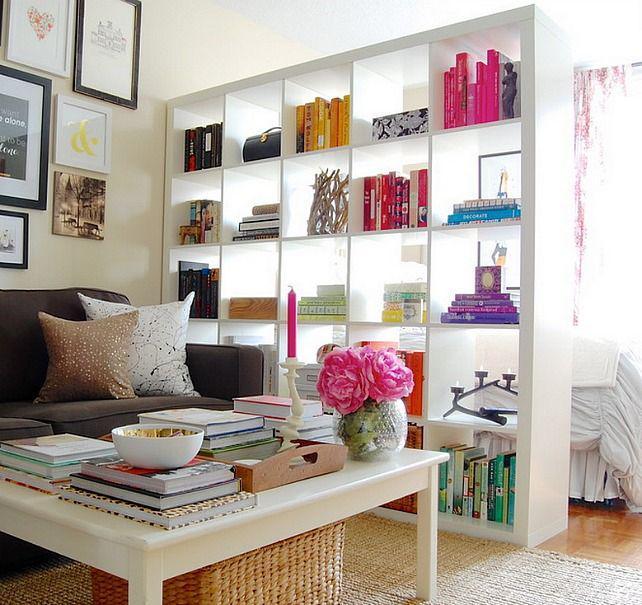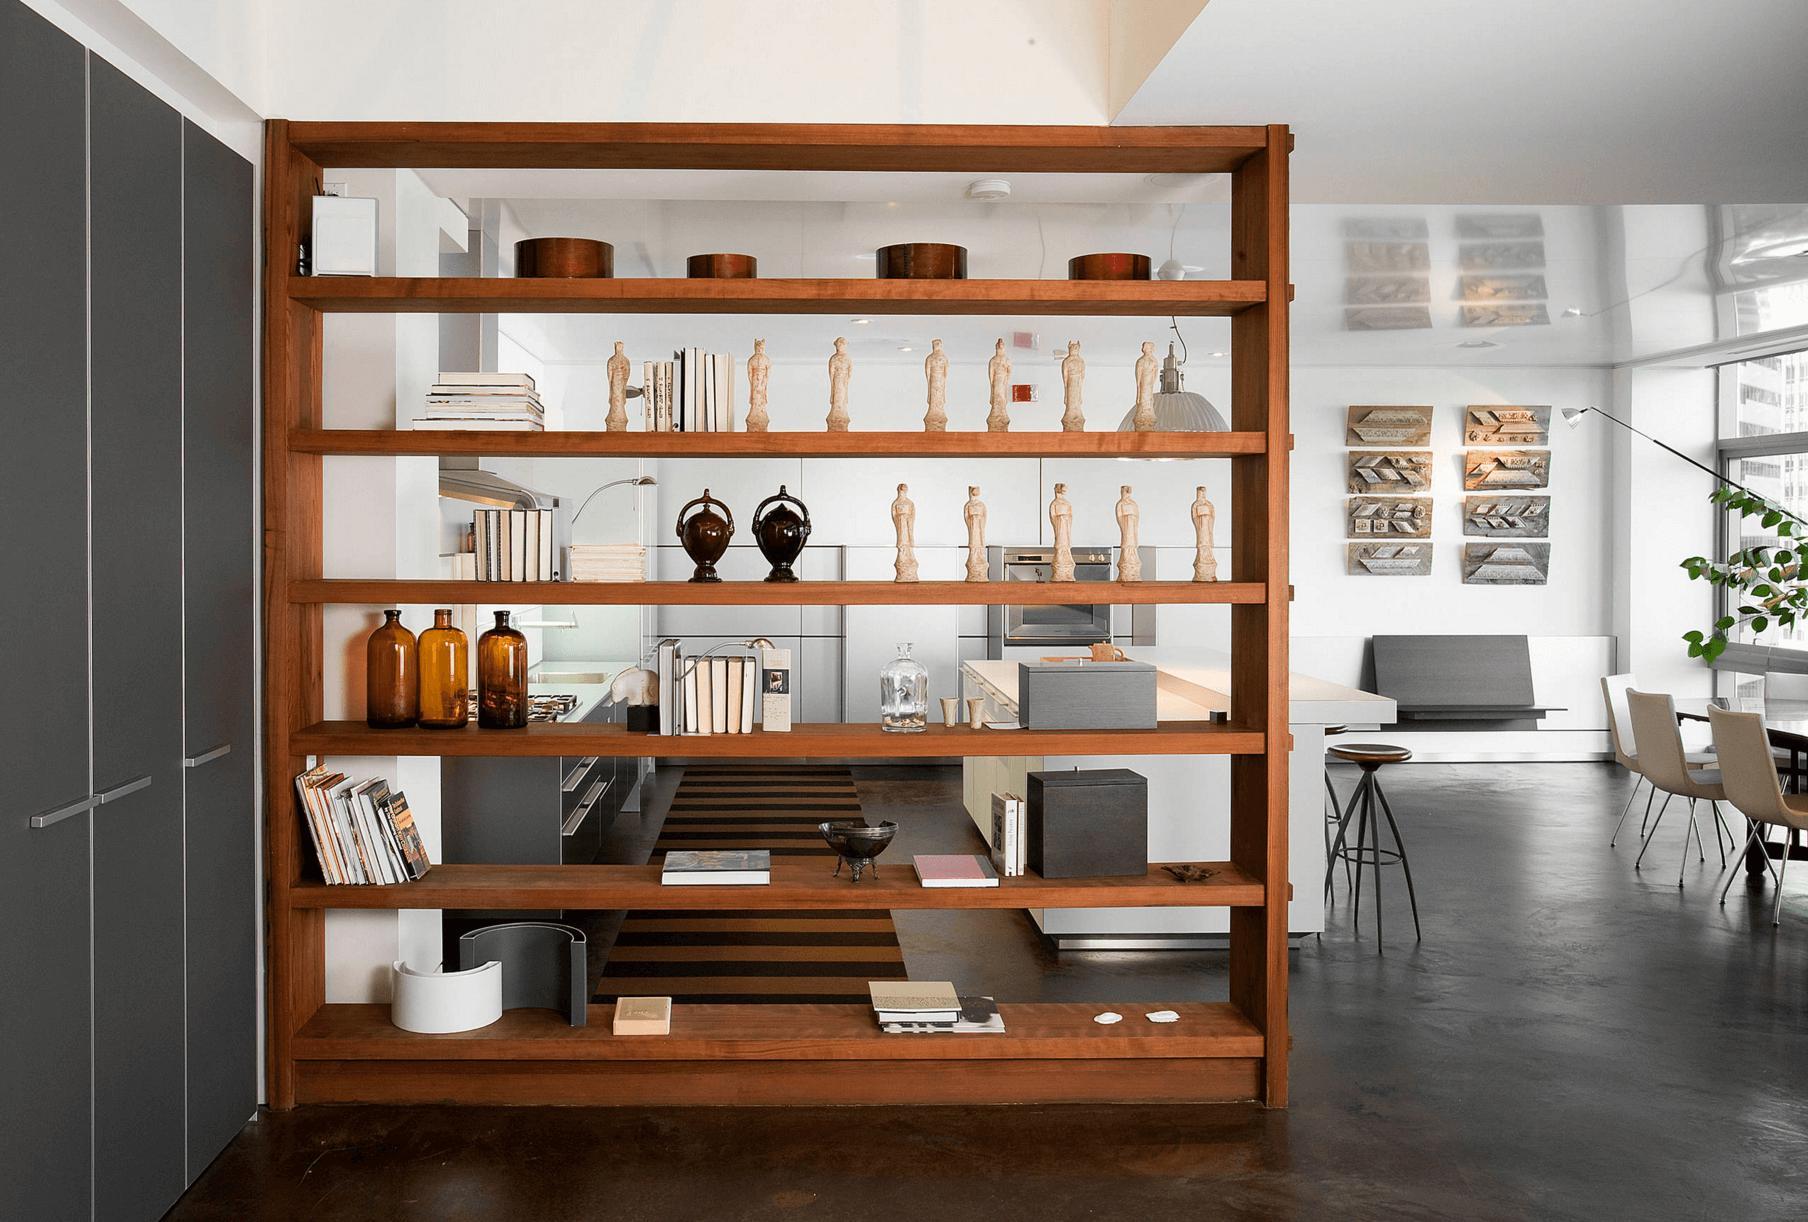The first image is the image on the left, the second image is the image on the right. Given the left and right images, does the statement "In one image, a white shelving unit surrounds a central door that is standing open, with floor-to-ceiling shelves on both sides and over the door." hold true? Answer yes or no. No. The first image is the image on the left, the second image is the image on the right. Examine the images to the left and right. Is the description "One room has an opened doorway through the middle of a wall of white bookshelves." accurate? Answer yes or no. No. 